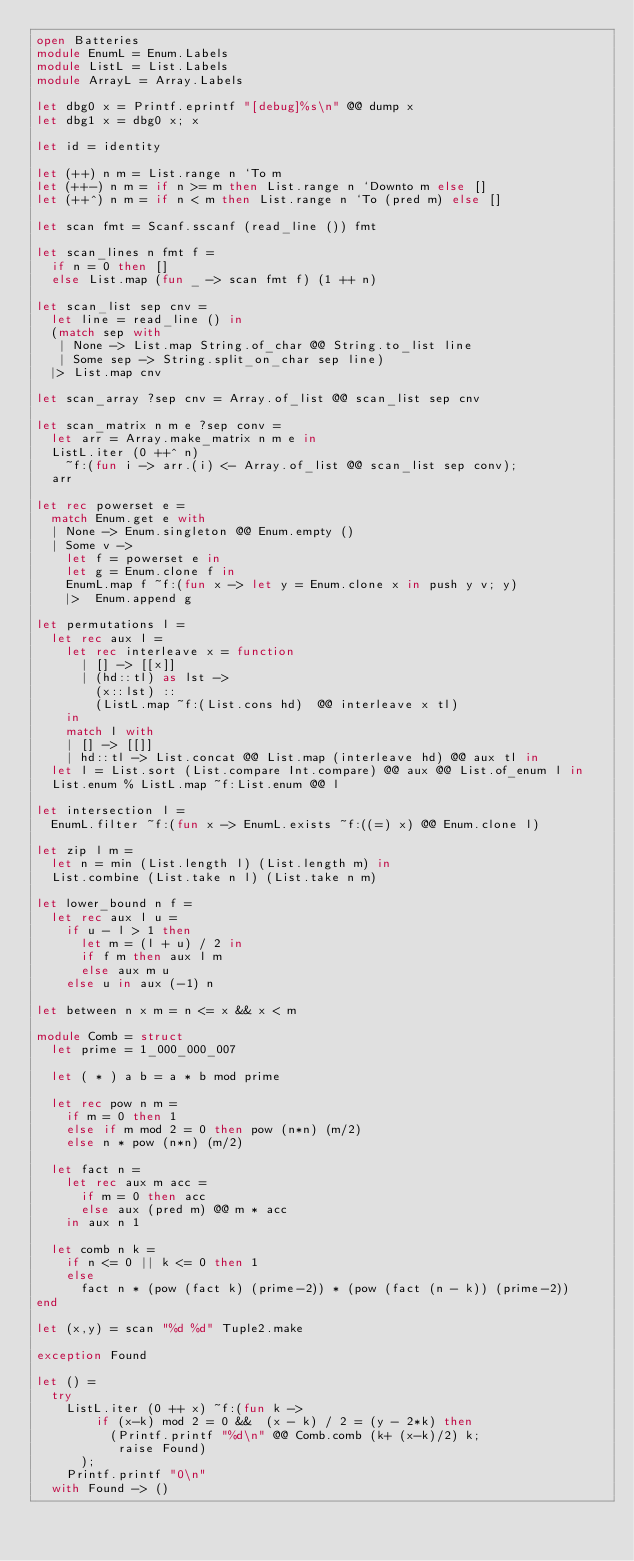<code> <loc_0><loc_0><loc_500><loc_500><_OCaml_>open Batteries
module EnumL = Enum.Labels
module ListL = List.Labels
module ArrayL = Array.Labels

let dbg0 x = Printf.eprintf "[debug]%s\n" @@ dump x
let dbg1 x = dbg0 x; x

let id = identity

let (++) n m = List.range n `To m
let (++-) n m = if n >= m then List.range n `Downto m else []
let (++^) n m = if n < m then List.range n `To (pred m) else []

let scan fmt = Scanf.sscanf (read_line ()) fmt

let scan_lines n fmt f =
  if n = 0 then []
  else List.map (fun _ -> scan fmt f) (1 ++ n)

let scan_list sep cnv =
  let line = read_line () in
  (match sep with
   | None -> List.map String.of_char @@ String.to_list line
   | Some sep -> String.split_on_char sep line)
  |> List.map cnv

let scan_array ?sep cnv = Array.of_list @@ scan_list sep cnv

let scan_matrix n m e ?sep conv =
  let arr = Array.make_matrix n m e in
  ListL.iter (0 ++^ n)
    ~f:(fun i -> arr.(i) <- Array.of_list @@ scan_list sep conv);
  arr

let rec powerset e =
  match Enum.get e with
  | None -> Enum.singleton @@ Enum.empty ()
  | Some v ->
    let f = powerset e in
    let g = Enum.clone f in
    EnumL.map f ~f:(fun x -> let y = Enum.clone x in push y v; y)
    |>  Enum.append g

let permutations l =
  let rec aux l =
    let rec interleave x = function
      | [] -> [[x]]
      | (hd::tl) as lst ->
        (x::lst) ::
        (ListL.map ~f:(List.cons hd)  @@ interleave x tl)
    in
    match l with
    | [] -> [[]]
    | hd::tl -> List.concat @@ List.map (interleave hd) @@ aux tl in
  let l = List.sort (List.compare Int.compare) @@ aux @@ List.of_enum l in
  List.enum % ListL.map ~f:List.enum @@ l

let intersection l =
  EnumL.filter ~f:(fun x -> EnumL.exists ~f:((=) x) @@ Enum.clone l)

let zip l m =
  let n = min (List.length l) (List.length m) in
  List.combine (List.take n l) (List.take n m)

let lower_bound n f =
  let rec aux l u =
    if u - l > 1 then
      let m = (l + u) / 2 in
      if f m then aux l m
      else aux m u
    else u in aux (-1) n

let between n x m = n <= x && x < m

module Comb = struct
  let prime = 1_000_000_007

  let ( * ) a b = a * b mod prime

  let rec pow n m =
    if m = 0 then 1
    else if m mod 2 = 0 then pow (n*n) (m/2)
    else n * pow (n*n) (m/2)

  let fact n =
    let rec aux m acc =
      if m = 0 then acc
      else aux (pred m) @@ m * acc
    in aux n 1

  let comb n k =
    if n <= 0 || k <= 0 then 1
    else
      fact n * (pow (fact k) (prime-2)) * (pow (fact (n - k)) (prime-2))
end

let (x,y) = scan "%d %d" Tuple2.make

exception Found

let () =
  try
    ListL.iter (0 ++ x) ~f:(fun k ->
        if (x-k) mod 2 = 0 &&  (x - k) / 2 = (y - 2*k) then
          (Printf.printf "%d\n" @@ Comb.comb (k+ (x-k)/2) k;
           raise Found)
      );
    Printf.printf "0\n"
  with Found -> ()
</code> 